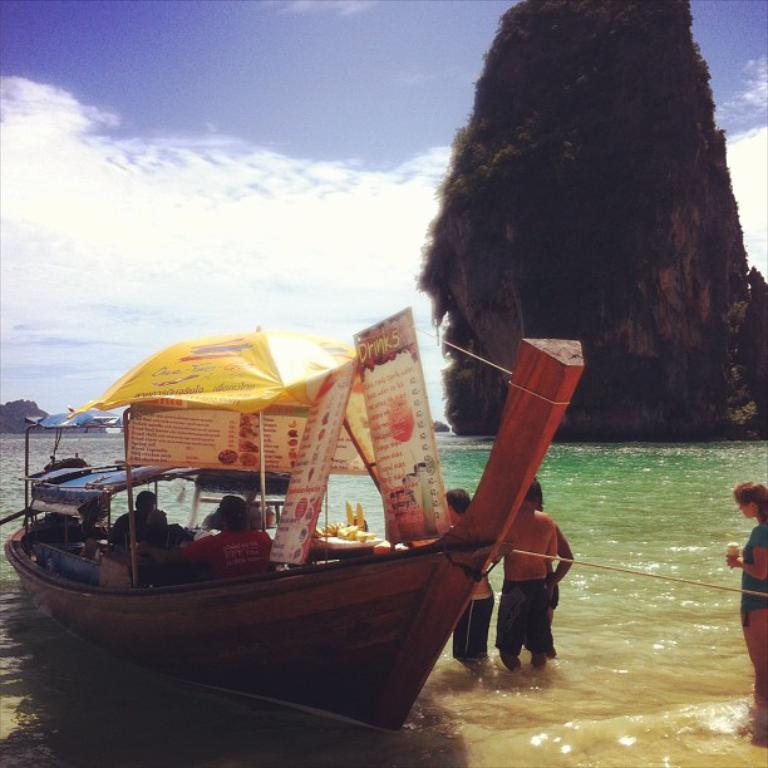What is the main subject of the image? The main subject of the image is a boat. Where is the boat located? The boat is on the water. Are there any people on the boat? Yes, there are persons on the boat. What additional features can be seen on the boat? There are banners and an umbrella on the boat. What can be seen in the background of the image? Mountains and the sky are visible in the background. What is the condition of the sky in the image? The sky is visible with clouds present. What type of flower is blooming on the door of the boat in the image? There is no door or flower present on the boat in the image. 